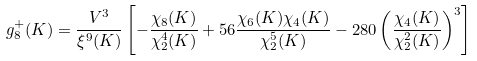Convert formula to latex. <formula><loc_0><loc_0><loc_500><loc_500>g ^ { + } _ { 8 } ( K ) = \frac { V ^ { 3 } } { \xi ^ { 9 } ( K ) } \left [ - \frac { \chi _ { 8 } ( K ) } { \chi _ { 2 } ^ { 4 } ( K ) } + 5 6 \frac { \chi _ { 6 } ( K ) \chi _ { 4 } ( K ) } { \chi _ { 2 } ^ { 5 } ( K ) } - 2 8 0 \left ( \frac { \chi _ { 4 } ( K ) } { \chi _ { 2 } ^ { 2 } ( K ) } \right ) ^ { 3 } \right ]</formula> 